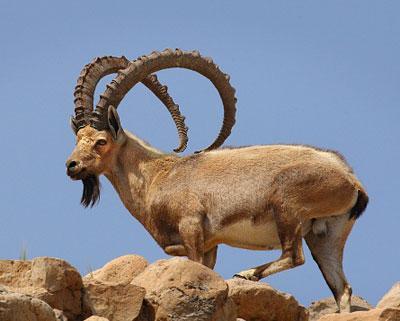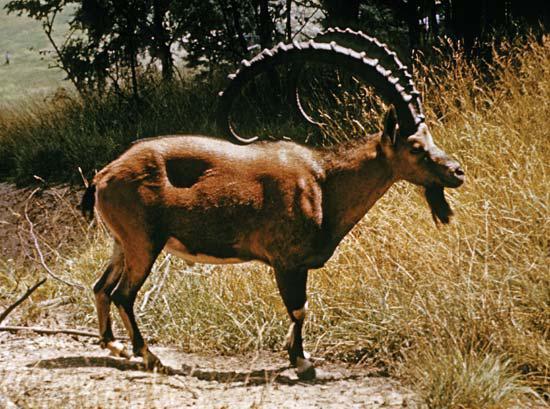The first image is the image on the left, the second image is the image on the right. For the images displayed, is the sentence "One animal is laying down." factually correct? Answer yes or no. No. 